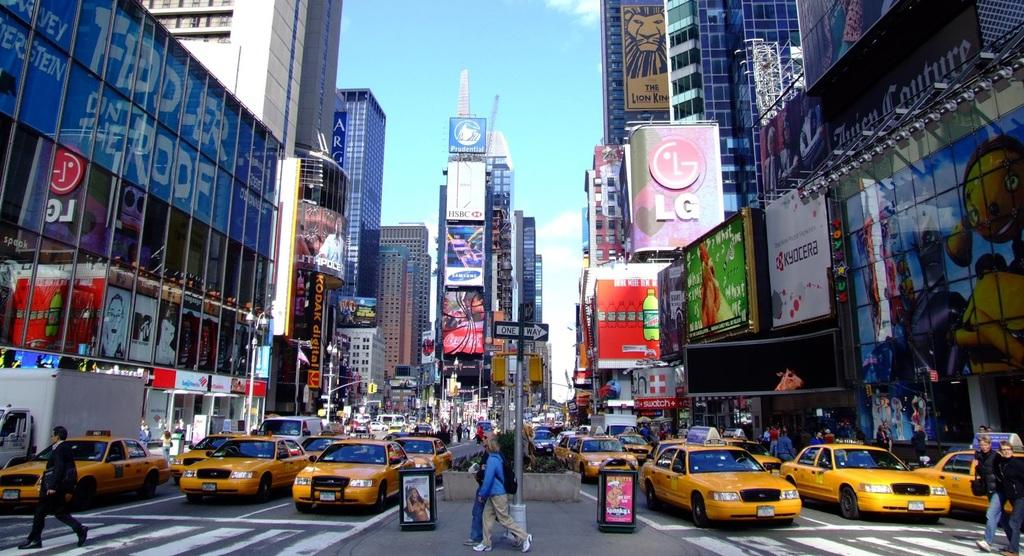<image>
Render a clear and concise summary of the photo. A city traffic scene with a Samsung ad in the middle. 